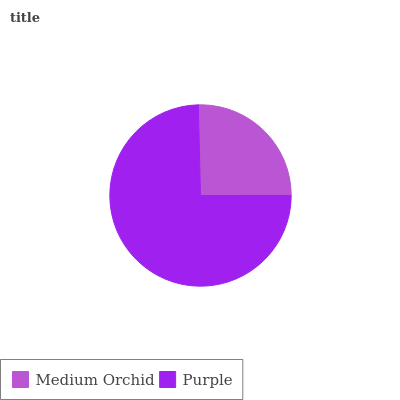Is Medium Orchid the minimum?
Answer yes or no. Yes. Is Purple the maximum?
Answer yes or no. Yes. Is Purple the minimum?
Answer yes or no. No. Is Purple greater than Medium Orchid?
Answer yes or no. Yes. Is Medium Orchid less than Purple?
Answer yes or no. Yes. Is Medium Orchid greater than Purple?
Answer yes or no. No. Is Purple less than Medium Orchid?
Answer yes or no. No. Is Purple the high median?
Answer yes or no. Yes. Is Medium Orchid the low median?
Answer yes or no. Yes. Is Medium Orchid the high median?
Answer yes or no. No. Is Purple the low median?
Answer yes or no. No. 